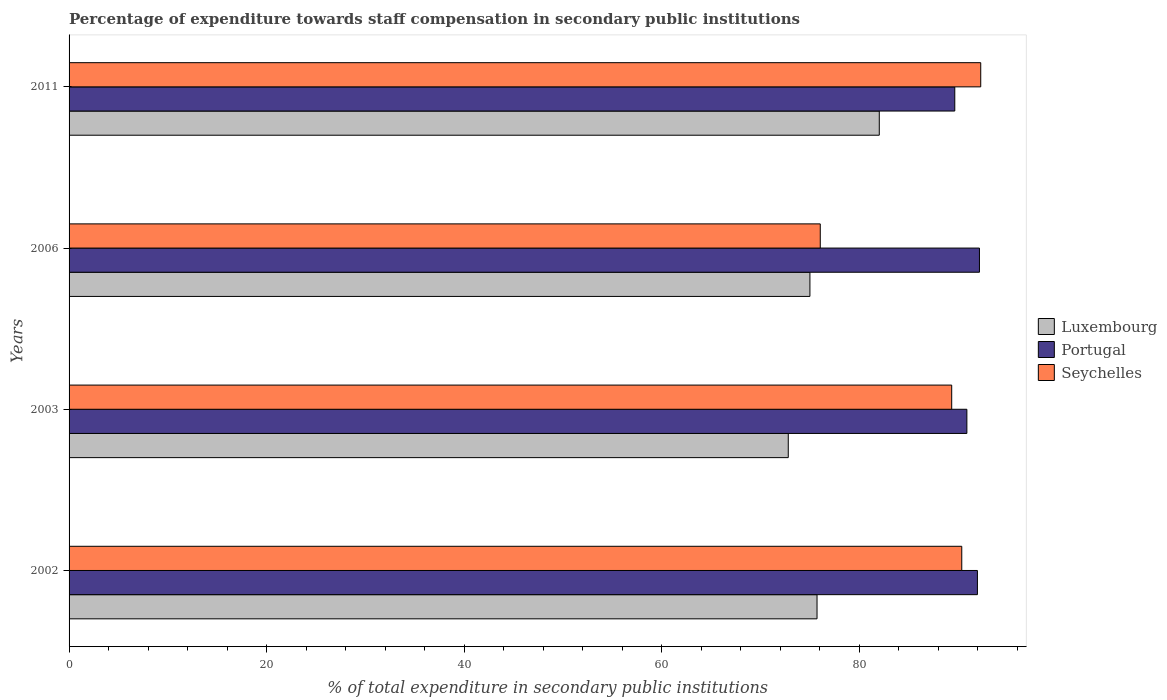How many groups of bars are there?
Your response must be concise. 4. Are the number of bars on each tick of the Y-axis equal?
Your response must be concise. Yes. How many bars are there on the 3rd tick from the bottom?
Offer a very short reply. 3. What is the label of the 1st group of bars from the top?
Ensure brevity in your answer.  2011. In how many cases, is the number of bars for a given year not equal to the number of legend labels?
Keep it short and to the point. 0. What is the percentage of expenditure towards staff compensation in Seychelles in 2006?
Make the answer very short. 76.06. Across all years, what is the maximum percentage of expenditure towards staff compensation in Seychelles?
Offer a terse response. 92.3. Across all years, what is the minimum percentage of expenditure towards staff compensation in Luxembourg?
Your response must be concise. 72.81. In which year was the percentage of expenditure towards staff compensation in Luxembourg maximum?
Keep it short and to the point. 2011. What is the total percentage of expenditure towards staff compensation in Luxembourg in the graph?
Offer a terse response. 305.58. What is the difference between the percentage of expenditure towards staff compensation in Seychelles in 2002 and that in 2003?
Your answer should be compact. 1.02. What is the difference between the percentage of expenditure towards staff compensation in Portugal in 2006 and the percentage of expenditure towards staff compensation in Luxembourg in 2003?
Your answer should be compact. 19.36. What is the average percentage of expenditure towards staff compensation in Seychelles per year?
Your answer should be compact. 87.02. In the year 2003, what is the difference between the percentage of expenditure towards staff compensation in Luxembourg and percentage of expenditure towards staff compensation in Seychelles?
Keep it short and to the point. -16.55. What is the ratio of the percentage of expenditure towards staff compensation in Seychelles in 2002 to that in 2003?
Your answer should be compact. 1.01. What is the difference between the highest and the second highest percentage of expenditure towards staff compensation in Portugal?
Ensure brevity in your answer.  0.21. What is the difference between the highest and the lowest percentage of expenditure towards staff compensation in Seychelles?
Offer a very short reply. 16.25. In how many years, is the percentage of expenditure towards staff compensation in Portugal greater than the average percentage of expenditure towards staff compensation in Portugal taken over all years?
Keep it short and to the point. 2. What does the 3rd bar from the top in 2002 represents?
Your answer should be compact. Luxembourg. What does the 3rd bar from the bottom in 2006 represents?
Give a very brief answer. Seychelles. Is it the case that in every year, the sum of the percentage of expenditure towards staff compensation in Luxembourg and percentage of expenditure towards staff compensation in Portugal is greater than the percentage of expenditure towards staff compensation in Seychelles?
Make the answer very short. Yes. How many bars are there?
Make the answer very short. 12. Are all the bars in the graph horizontal?
Provide a short and direct response. Yes. How many years are there in the graph?
Your answer should be compact. 4. What is the difference between two consecutive major ticks on the X-axis?
Provide a short and direct response. 20. Are the values on the major ticks of X-axis written in scientific E-notation?
Offer a very short reply. No. Does the graph contain any zero values?
Your answer should be compact. No. Does the graph contain grids?
Your response must be concise. No. How many legend labels are there?
Give a very brief answer. 3. What is the title of the graph?
Your response must be concise. Percentage of expenditure towards staff compensation in secondary public institutions. Does "Tunisia" appear as one of the legend labels in the graph?
Offer a terse response. No. What is the label or title of the X-axis?
Make the answer very short. % of total expenditure in secondary public institutions. What is the % of total expenditure in secondary public institutions in Luxembourg in 2002?
Offer a terse response. 75.73. What is the % of total expenditure in secondary public institutions in Portugal in 2002?
Offer a terse response. 91.97. What is the % of total expenditure in secondary public institutions in Seychelles in 2002?
Provide a succinct answer. 90.38. What is the % of total expenditure in secondary public institutions in Luxembourg in 2003?
Keep it short and to the point. 72.81. What is the % of total expenditure in secondary public institutions of Portugal in 2003?
Offer a terse response. 90.9. What is the % of total expenditure in secondary public institutions in Seychelles in 2003?
Give a very brief answer. 89.36. What is the % of total expenditure in secondary public institutions of Luxembourg in 2006?
Make the answer very short. 75.01. What is the % of total expenditure in secondary public institutions in Portugal in 2006?
Give a very brief answer. 92.17. What is the % of total expenditure in secondary public institutions in Seychelles in 2006?
Offer a terse response. 76.06. What is the % of total expenditure in secondary public institutions in Luxembourg in 2011?
Give a very brief answer. 82.03. What is the % of total expenditure in secondary public institutions in Portugal in 2011?
Your answer should be very brief. 89.67. What is the % of total expenditure in secondary public institutions of Seychelles in 2011?
Your answer should be compact. 92.3. Across all years, what is the maximum % of total expenditure in secondary public institutions in Luxembourg?
Your response must be concise. 82.03. Across all years, what is the maximum % of total expenditure in secondary public institutions in Portugal?
Provide a short and direct response. 92.17. Across all years, what is the maximum % of total expenditure in secondary public institutions of Seychelles?
Your answer should be compact. 92.3. Across all years, what is the minimum % of total expenditure in secondary public institutions in Luxembourg?
Give a very brief answer. 72.81. Across all years, what is the minimum % of total expenditure in secondary public institutions in Portugal?
Provide a succinct answer. 89.67. Across all years, what is the minimum % of total expenditure in secondary public institutions in Seychelles?
Ensure brevity in your answer.  76.06. What is the total % of total expenditure in secondary public institutions in Luxembourg in the graph?
Offer a very short reply. 305.58. What is the total % of total expenditure in secondary public institutions of Portugal in the graph?
Keep it short and to the point. 364.71. What is the total % of total expenditure in secondary public institutions in Seychelles in the graph?
Your response must be concise. 348.1. What is the difference between the % of total expenditure in secondary public institutions in Luxembourg in 2002 and that in 2003?
Your answer should be very brief. 2.91. What is the difference between the % of total expenditure in secondary public institutions of Portugal in 2002 and that in 2003?
Your answer should be compact. 1.07. What is the difference between the % of total expenditure in secondary public institutions in Seychelles in 2002 and that in 2003?
Make the answer very short. 1.02. What is the difference between the % of total expenditure in secondary public institutions in Luxembourg in 2002 and that in 2006?
Give a very brief answer. 0.72. What is the difference between the % of total expenditure in secondary public institutions in Portugal in 2002 and that in 2006?
Ensure brevity in your answer.  -0.21. What is the difference between the % of total expenditure in secondary public institutions in Seychelles in 2002 and that in 2006?
Give a very brief answer. 14.33. What is the difference between the % of total expenditure in secondary public institutions in Luxembourg in 2002 and that in 2011?
Your answer should be very brief. -6.3. What is the difference between the % of total expenditure in secondary public institutions of Portugal in 2002 and that in 2011?
Your answer should be compact. 2.29. What is the difference between the % of total expenditure in secondary public institutions of Seychelles in 2002 and that in 2011?
Offer a terse response. -1.92. What is the difference between the % of total expenditure in secondary public institutions of Luxembourg in 2003 and that in 2006?
Keep it short and to the point. -2.19. What is the difference between the % of total expenditure in secondary public institutions of Portugal in 2003 and that in 2006?
Offer a very short reply. -1.27. What is the difference between the % of total expenditure in secondary public institutions of Seychelles in 2003 and that in 2006?
Give a very brief answer. 13.31. What is the difference between the % of total expenditure in secondary public institutions in Luxembourg in 2003 and that in 2011?
Make the answer very short. -9.21. What is the difference between the % of total expenditure in secondary public institutions of Portugal in 2003 and that in 2011?
Your answer should be very brief. 1.22. What is the difference between the % of total expenditure in secondary public institutions of Seychelles in 2003 and that in 2011?
Make the answer very short. -2.94. What is the difference between the % of total expenditure in secondary public institutions in Luxembourg in 2006 and that in 2011?
Keep it short and to the point. -7.02. What is the difference between the % of total expenditure in secondary public institutions in Portugal in 2006 and that in 2011?
Give a very brief answer. 2.5. What is the difference between the % of total expenditure in secondary public institutions of Seychelles in 2006 and that in 2011?
Ensure brevity in your answer.  -16.25. What is the difference between the % of total expenditure in secondary public institutions of Luxembourg in 2002 and the % of total expenditure in secondary public institutions of Portugal in 2003?
Ensure brevity in your answer.  -15.17. What is the difference between the % of total expenditure in secondary public institutions in Luxembourg in 2002 and the % of total expenditure in secondary public institutions in Seychelles in 2003?
Provide a succinct answer. -13.64. What is the difference between the % of total expenditure in secondary public institutions of Portugal in 2002 and the % of total expenditure in secondary public institutions of Seychelles in 2003?
Ensure brevity in your answer.  2.6. What is the difference between the % of total expenditure in secondary public institutions in Luxembourg in 2002 and the % of total expenditure in secondary public institutions in Portugal in 2006?
Keep it short and to the point. -16.44. What is the difference between the % of total expenditure in secondary public institutions in Luxembourg in 2002 and the % of total expenditure in secondary public institutions in Seychelles in 2006?
Your answer should be very brief. -0.33. What is the difference between the % of total expenditure in secondary public institutions in Portugal in 2002 and the % of total expenditure in secondary public institutions in Seychelles in 2006?
Give a very brief answer. 15.91. What is the difference between the % of total expenditure in secondary public institutions of Luxembourg in 2002 and the % of total expenditure in secondary public institutions of Portugal in 2011?
Offer a very short reply. -13.95. What is the difference between the % of total expenditure in secondary public institutions in Luxembourg in 2002 and the % of total expenditure in secondary public institutions in Seychelles in 2011?
Ensure brevity in your answer.  -16.57. What is the difference between the % of total expenditure in secondary public institutions of Portugal in 2002 and the % of total expenditure in secondary public institutions of Seychelles in 2011?
Provide a succinct answer. -0.34. What is the difference between the % of total expenditure in secondary public institutions of Luxembourg in 2003 and the % of total expenditure in secondary public institutions of Portugal in 2006?
Provide a succinct answer. -19.36. What is the difference between the % of total expenditure in secondary public institutions in Luxembourg in 2003 and the % of total expenditure in secondary public institutions in Seychelles in 2006?
Your answer should be compact. -3.24. What is the difference between the % of total expenditure in secondary public institutions in Portugal in 2003 and the % of total expenditure in secondary public institutions in Seychelles in 2006?
Keep it short and to the point. 14.84. What is the difference between the % of total expenditure in secondary public institutions of Luxembourg in 2003 and the % of total expenditure in secondary public institutions of Portugal in 2011?
Ensure brevity in your answer.  -16.86. What is the difference between the % of total expenditure in secondary public institutions in Luxembourg in 2003 and the % of total expenditure in secondary public institutions in Seychelles in 2011?
Your answer should be compact. -19.49. What is the difference between the % of total expenditure in secondary public institutions in Portugal in 2003 and the % of total expenditure in secondary public institutions in Seychelles in 2011?
Offer a terse response. -1.4. What is the difference between the % of total expenditure in secondary public institutions of Luxembourg in 2006 and the % of total expenditure in secondary public institutions of Portugal in 2011?
Offer a very short reply. -14.67. What is the difference between the % of total expenditure in secondary public institutions of Luxembourg in 2006 and the % of total expenditure in secondary public institutions of Seychelles in 2011?
Ensure brevity in your answer.  -17.29. What is the difference between the % of total expenditure in secondary public institutions of Portugal in 2006 and the % of total expenditure in secondary public institutions of Seychelles in 2011?
Offer a terse response. -0.13. What is the average % of total expenditure in secondary public institutions of Luxembourg per year?
Give a very brief answer. 76.39. What is the average % of total expenditure in secondary public institutions in Portugal per year?
Keep it short and to the point. 91.18. What is the average % of total expenditure in secondary public institutions of Seychelles per year?
Your answer should be compact. 87.02. In the year 2002, what is the difference between the % of total expenditure in secondary public institutions of Luxembourg and % of total expenditure in secondary public institutions of Portugal?
Ensure brevity in your answer.  -16.24. In the year 2002, what is the difference between the % of total expenditure in secondary public institutions in Luxembourg and % of total expenditure in secondary public institutions in Seychelles?
Your answer should be very brief. -14.65. In the year 2002, what is the difference between the % of total expenditure in secondary public institutions in Portugal and % of total expenditure in secondary public institutions in Seychelles?
Give a very brief answer. 1.59. In the year 2003, what is the difference between the % of total expenditure in secondary public institutions in Luxembourg and % of total expenditure in secondary public institutions in Portugal?
Keep it short and to the point. -18.08. In the year 2003, what is the difference between the % of total expenditure in secondary public institutions of Luxembourg and % of total expenditure in secondary public institutions of Seychelles?
Provide a short and direct response. -16.55. In the year 2003, what is the difference between the % of total expenditure in secondary public institutions in Portugal and % of total expenditure in secondary public institutions in Seychelles?
Your answer should be very brief. 1.54. In the year 2006, what is the difference between the % of total expenditure in secondary public institutions of Luxembourg and % of total expenditure in secondary public institutions of Portugal?
Your response must be concise. -17.16. In the year 2006, what is the difference between the % of total expenditure in secondary public institutions in Luxembourg and % of total expenditure in secondary public institutions in Seychelles?
Offer a terse response. -1.05. In the year 2006, what is the difference between the % of total expenditure in secondary public institutions in Portugal and % of total expenditure in secondary public institutions in Seychelles?
Your answer should be very brief. 16.12. In the year 2011, what is the difference between the % of total expenditure in secondary public institutions in Luxembourg and % of total expenditure in secondary public institutions in Portugal?
Provide a succinct answer. -7.64. In the year 2011, what is the difference between the % of total expenditure in secondary public institutions in Luxembourg and % of total expenditure in secondary public institutions in Seychelles?
Provide a short and direct response. -10.27. In the year 2011, what is the difference between the % of total expenditure in secondary public institutions in Portugal and % of total expenditure in secondary public institutions in Seychelles?
Offer a terse response. -2.63. What is the ratio of the % of total expenditure in secondary public institutions of Luxembourg in 2002 to that in 2003?
Offer a very short reply. 1.04. What is the ratio of the % of total expenditure in secondary public institutions in Portugal in 2002 to that in 2003?
Offer a very short reply. 1.01. What is the ratio of the % of total expenditure in secondary public institutions in Seychelles in 2002 to that in 2003?
Provide a short and direct response. 1.01. What is the ratio of the % of total expenditure in secondary public institutions in Luxembourg in 2002 to that in 2006?
Your answer should be compact. 1.01. What is the ratio of the % of total expenditure in secondary public institutions in Portugal in 2002 to that in 2006?
Provide a short and direct response. 1. What is the ratio of the % of total expenditure in secondary public institutions of Seychelles in 2002 to that in 2006?
Give a very brief answer. 1.19. What is the ratio of the % of total expenditure in secondary public institutions in Luxembourg in 2002 to that in 2011?
Your answer should be very brief. 0.92. What is the ratio of the % of total expenditure in secondary public institutions of Portugal in 2002 to that in 2011?
Provide a short and direct response. 1.03. What is the ratio of the % of total expenditure in secondary public institutions of Seychelles in 2002 to that in 2011?
Provide a short and direct response. 0.98. What is the ratio of the % of total expenditure in secondary public institutions in Luxembourg in 2003 to that in 2006?
Offer a terse response. 0.97. What is the ratio of the % of total expenditure in secondary public institutions of Portugal in 2003 to that in 2006?
Provide a short and direct response. 0.99. What is the ratio of the % of total expenditure in secondary public institutions of Seychelles in 2003 to that in 2006?
Make the answer very short. 1.18. What is the ratio of the % of total expenditure in secondary public institutions in Luxembourg in 2003 to that in 2011?
Offer a terse response. 0.89. What is the ratio of the % of total expenditure in secondary public institutions in Portugal in 2003 to that in 2011?
Your answer should be compact. 1.01. What is the ratio of the % of total expenditure in secondary public institutions in Seychelles in 2003 to that in 2011?
Provide a short and direct response. 0.97. What is the ratio of the % of total expenditure in secondary public institutions in Luxembourg in 2006 to that in 2011?
Provide a short and direct response. 0.91. What is the ratio of the % of total expenditure in secondary public institutions in Portugal in 2006 to that in 2011?
Your response must be concise. 1.03. What is the ratio of the % of total expenditure in secondary public institutions in Seychelles in 2006 to that in 2011?
Offer a terse response. 0.82. What is the difference between the highest and the second highest % of total expenditure in secondary public institutions of Luxembourg?
Make the answer very short. 6.3. What is the difference between the highest and the second highest % of total expenditure in secondary public institutions in Portugal?
Offer a very short reply. 0.21. What is the difference between the highest and the second highest % of total expenditure in secondary public institutions of Seychelles?
Provide a short and direct response. 1.92. What is the difference between the highest and the lowest % of total expenditure in secondary public institutions in Luxembourg?
Provide a short and direct response. 9.21. What is the difference between the highest and the lowest % of total expenditure in secondary public institutions of Portugal?
Provide a short and direct response. 2.5. What is the difference between the highest and the lowest % of total expenditure in secondary public institutions of Seychelles?
Offer a very short reply. 16.25. 